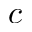Convert formula to latex. <formula><loc_0><loc_0><loc_500><loc_500>c</formula> 